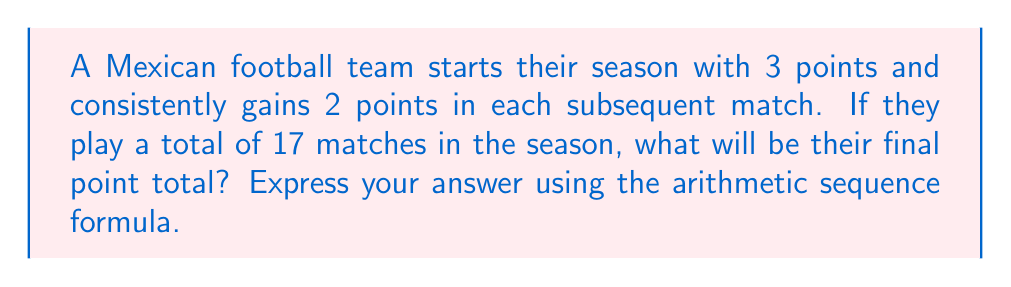Provide a solution to this math problem. Let's approach this step-by-step using the arithmetic sequence formula:

1) In an arithmetic sequence, we use the formula:
   $$ S_n = \frac{n}{2}(a_1 + a_n) $$
   where $S_n$ is the sum of the sequence, $n$ is the number of terms, $a_1$ is the first term, and $a_n$ is the last term.

2) We know:
   - $a_1 = 3$ (starting points)
   - $n = 17$ (number of matches)
   - The common difference $d = 2$ (points gained each match)

3) To find $a_n$, we use the formula:
   $$ a_n = a_1 + (n-1)d $$
   $$ a_{17} = 3 + (17-1)2 = 3 + 32 = 35 $$

4) Now we can plug these values into our sum formula:
   $$ S_{17} = \frac{17}{2}(3 + 35) $$

5) Simplify:
   $$ S_{17} = \frac{17}{2}(38) = 17 \times 19 = 323 $$

Therefore, the team's final point total will be 323 points.
Answer: $$ S_{17} = \frac{17}{2}(3 + 35) = 323 $$ 